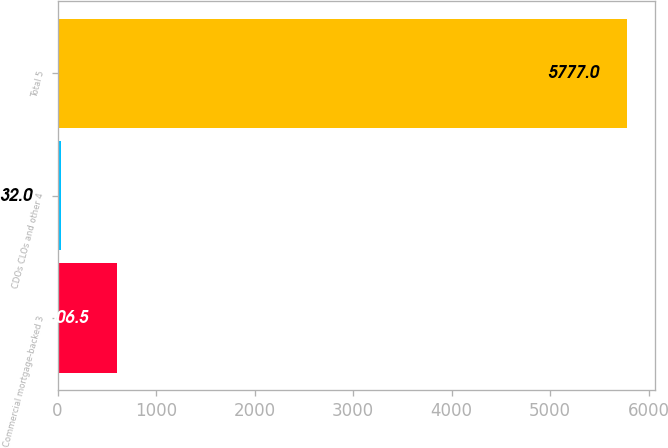Convert chart to OTSL. <chart><loc_0><loc_0><loc_500><loc_500><bar_chart><fcel>Commercial mortgage-backed 3<fcel>CDOs CLOs and other 4<fcel>Total 5<nl><fcel>606.5<fcel>32<fcel>5777<nl></chart> 